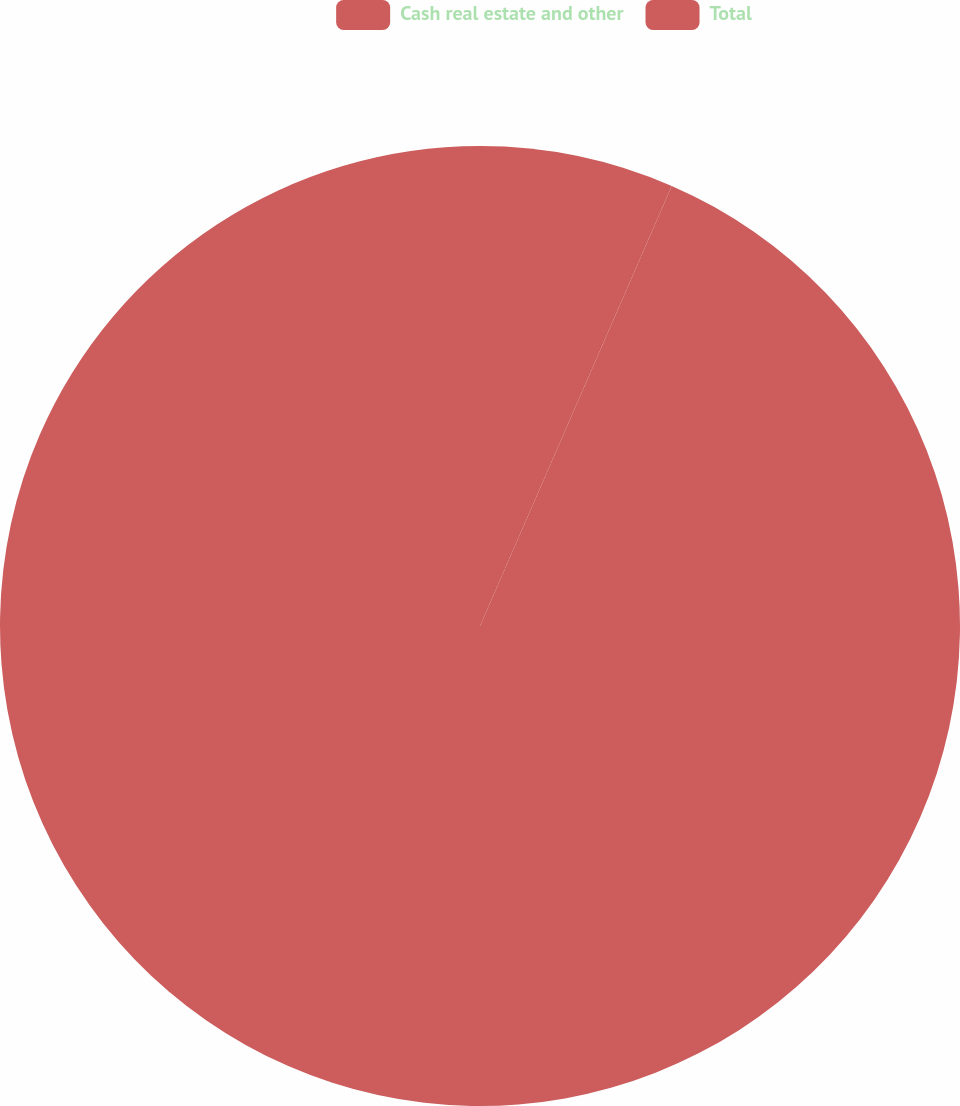<chart> <loc_0><loc_0><loc_500><loc_500><pie_chart><fcel>Cash real estate and other<fcel>Total<nl><fcel>6.54%<fcel>93.46%<nl></chart> 